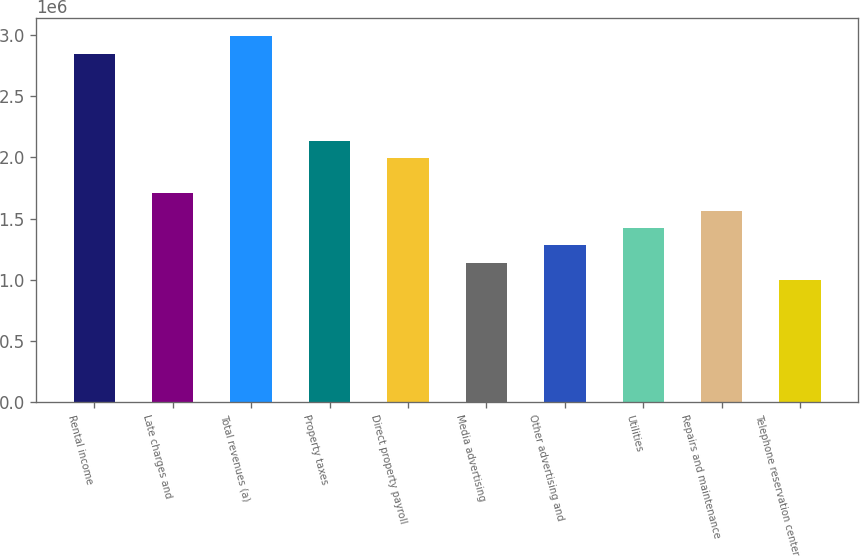Convert chart. <chart><loc_0><loc_0><loc_500><loc_500><bar_chart><fcel>Rental income<fcel>Late charges and<fcel>Total revenues (a)<fcel>Property taxes<fcel>Direct property payroll<fcel>Media advertising<fcel>Other advertising and<fcel>Utilities<fcel>Repairs and maintenance<fcel>Telephone reservation center<nl><fcel>2.84666e+06<fcel>1.708e+06<fcel>2.989e+06<fcel>2.135e+06<fcel>1.99267e+06<fcel>1.13867e+06<fcel>1.28101e+06<fcel>1.42334e+06<fcel>1.56567e+06<fcel>996340<nl></chart> 